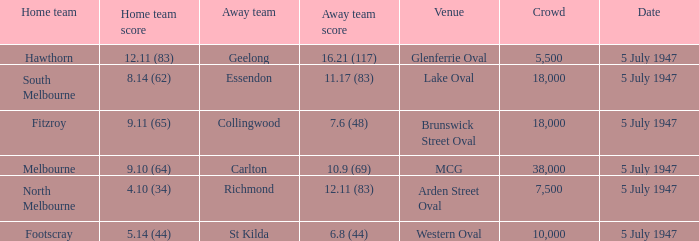Against which team did footscray play as the home side? St Kilda. 